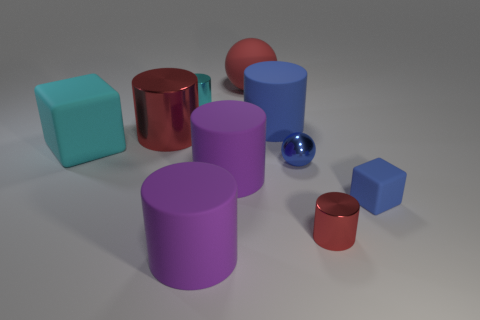What shape is the tiny matte object that is the same color as the small shiny sphere?
Provide a succinct answer. Cube. There is a metallic object that is the same color as the big block; what size is it?
Keep it short and to the point. Small. How many other things are there of the same shape as the tiny red thing?
Provide a short and direct response. 5. What color is the large rubber cylinder behind the small blue sphere?
Provide a short and direct response. Blue. Do the cyan cube and the red matte thing have the same size?
Offer a very short reply. Yes. There is a red sphere to the left of the small blue rubber thing that is in front of the big red shiny thing; what is it made of?
Your response must be concise. Rubber. What number of other large rubber cubes are the same color as the big matte cube?
Offer a very short reply. 0. Are there any other things that are made of the same material as the blue cube?
Offer a terse response. Yes. Is the number of red objects that are in front of the small blue metal sphere less than the number of big cyan rubber objects?
Provide a succinct answer. No. What is the color of the tiny cylinder to the left of the large red thing to the right of the big red shiny cylinder?
Offer a terse response. Cyan. 